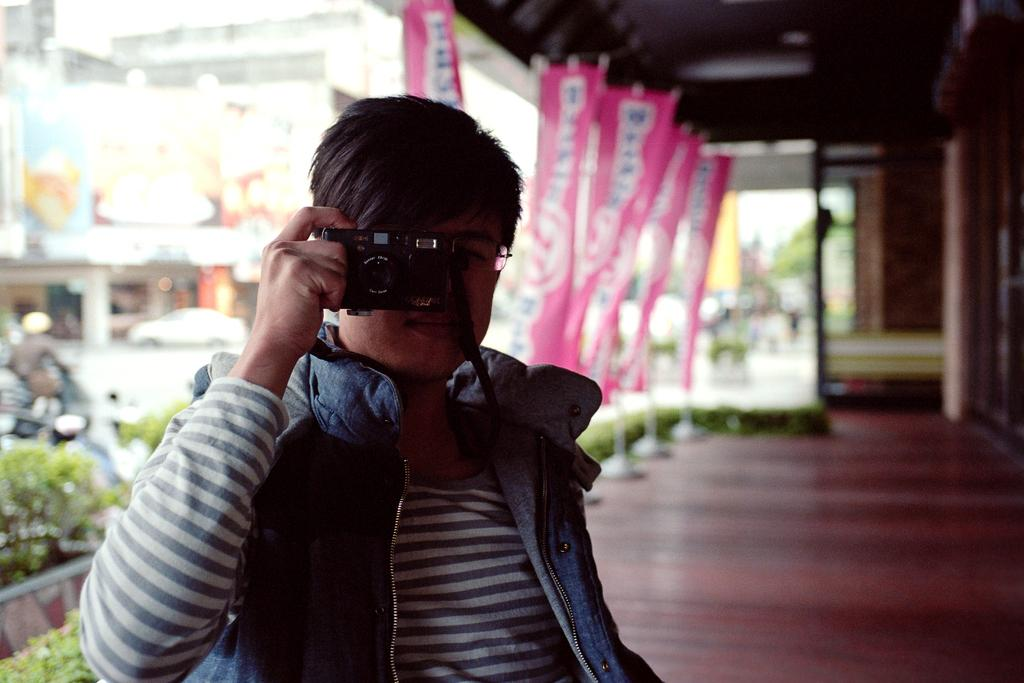What type of structures can be seen in the image? There are buildings in the image. What else is happening in the image besides the presence of buildings? There are vehicles moving in the image, and there are plants present as well. Can you describe the man in the image? The man is holding a camera in the image, and he is taking a picture. What else can be seen hanging in the image? There are banners hanging in the image. What type of ornament is the governor wearing in the image? There is no governor or ornament present in the image. What does the man use to store his pictures in the image? The man is holding a camera in the image, not a locket or any other storage device for pictures. 